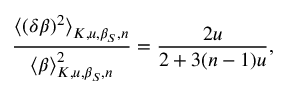Convert formula to latex. <formula><loc_0><loc_0><loc_500><loc_500>\frac { \Big < ( \delta \beta ) ^ { 2 } \Big > _ { K , u , \beta _ { S } , n } } { \Big < \beta \Big > _ { K , u , \beta _ { S } , n } ^ { 2 } } = \frac { 2 u } { 2 + 3 ( n - 1 ) u } ,</formula> 